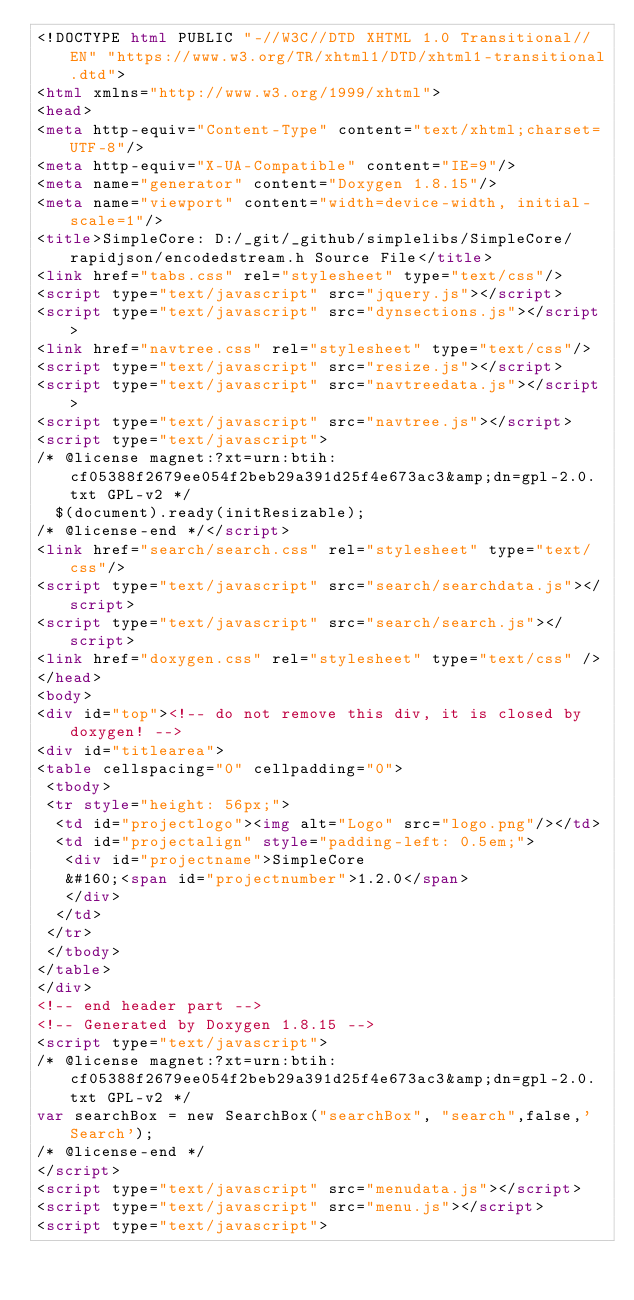Convert code to text. <code><loc_0><loc_0><loc_500><loc_500><_HTML_><!DOCTYPE html PUBLIC "-//W3C//DTD XHTML 1.0 Transitional//EN" "https://www.w3.org/TR/xhtml1/DTD/xhtml1-transitional.dtd">
<html xmlns="http://www.w3.org/1999/xhtml">
<head>
<meta http-equiv="Content-Type" content="text/xhtml;charset=UTF-8"/>
<meta http-equiv="X-UA-Compatible" content="IE=9"/>
<meta name="generator" content="Doxygen 1.8.15"/>
<meta name="viewport" content="width=device-width, initial-scale=1"/>
<title>SimpleCore: D:/_git/_github/simplelibs/SimpleCore/rapidjson/encodedstream.h Source File</title>
<link href="tabs.css" rel="stylesheet" type="text/css"/>
<script type="text/javascript" src="jquery.js"></script>
<script type="text/javascript" src="dynsections.js"></script>
<link href="navtree.css" rel="stylesheet" type="text/css"/>
<script type="text/javascript" src="resize.js"></script>
<script type="text/javascript" src="navtreedata.js"></script>
<script type="text/javascript" src="navtree.js"></script>
<script type="text/javascript">
/* @license magnet:?xt=urn:btih:cf05388f2679ee054f2beb29a391d25f4e673ac3&amp;dn=gpl-2.0.txt GPL-v2 */
  $(document).ready(initResizable);
/* @license-end */</script>
<link href="search/search.css" rel="stylesheet" type="text/css"/>
<script type="text/javascript" src="search/searchdata.js"></script>
<script type="text/javascript" src="search/search.js"></script>
<link href="doxygen.css" rel="stylesheet" type="text/css" />
</head>
<body>
<div id="top"><!-- do not remove this div, it is closed by doxygen! -->
<div id="titlearea">
<table cellspacing="0" cellpadding="0">
 <tbody>
 <tr style="height: 56px;">
  <td id="projectlogo"><img alt="Logo" src="logo.png"/></td>
  <td id="projectalign" style="padding-left: 0.5em;">
   <div id="projectname">SimpleCore
   &#160;<span id="projectnumber">1.2.0</span>
   </div>
  </td>
 </tr>
 </tbody>
</table>
</div>
<!-- end header part -->
<!-- Generated by Doxygen 1.8.15 -->
<script type="text/javascript">
/* @license magnet:?xt=urn:btih:cf05388f2679ee054f2beb29a391d25f4e673ac3&amp;dn=gpl-2.0.txt GPL-v2 */
var searchBox = new SearchBox("searchBox", "search",false,'Search');
/* @license-end */
</script>
<script type="text/javascript" src="menudata.js"></script>
<script type="text/javascript" src="menu.js"></script>
<script type="text/javascript"></code> 